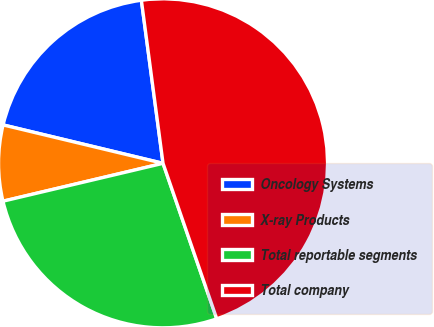Convert chart to OTSL. <chart><loc_0><loc_0><loc_500><loc_500><pie_chart><fcel>Oncology Systems<fcel>X-ray Products<fcel>Total reportable segments<fcel>Total company<nl><fcel>19.15%<fcel>7.45%<fcel>26.6%<fcel>46.81%<nl></chart> 